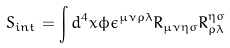Convert formula to latex. <formula><loc_0><loc_0><loc_500><loc_500>S _ { i n t } = \int d ^ { 4 } x \phi \epsilon ^ { \mu \nu \rho \lambda } R _ { \mu \nu \eta \sigma } R _ { \rho \lambda } ^ { \eta \sigma }</formula> 